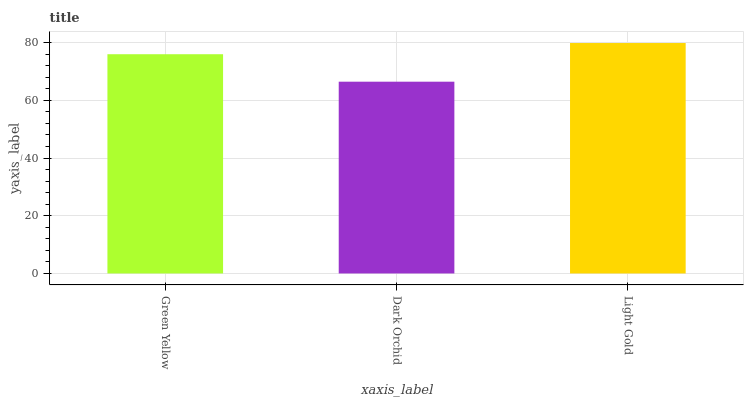Is Light Gold the minimum?
Answer yes or no. No. Is Dark Orchid the maximum?
Answer yes or no. No. Is Light Gold greater than Dark Orchid?
Answer yes or no. Yes. Is Dark Orchid less than Light Gold?
Answer yes or no. Yes. Is Dark Orchid greater than Light Gold?
Answer yes or no. No. Is Light Gold less than Dark Orchid?
Answer yes or no. No. Is Green Yellow the high median?
Answer yes or no. Yes. Is Green Yellow the low median?
Answer yes or no. Yes. Is Light Gold the high median?
Answer yes or no. No. Is Dark Orchid the low median?
Answer yes or no. No. 